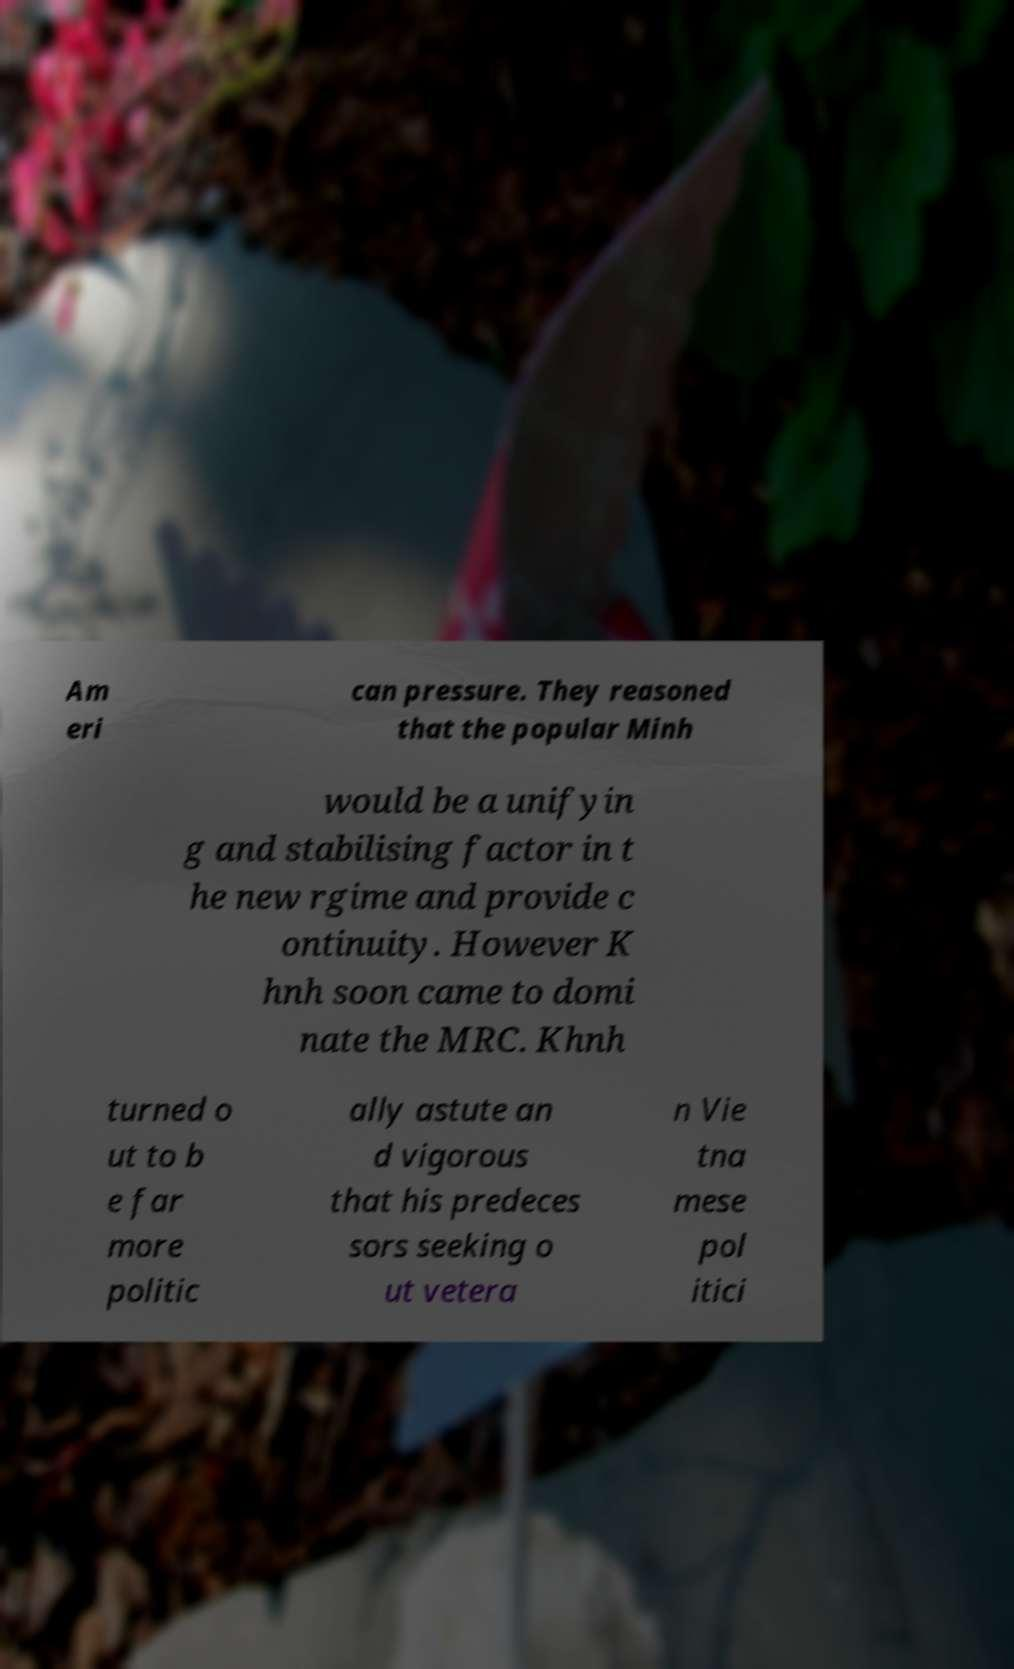Can you read and provide the text displayed in the image?This photo seems to have some interesting text. Can you extract and type it out for me? Am eri can pressure. They reasoned that the popular Minh would be a unifyin g and stabilising factor in t he new rgime and provide c ontinuity. However K hnh soon came to domi nate the MRC. Khnh turned o ut to b e far more politic ally astute an d vigorous that his predeces sors seeking o ut vetera n Vie tna mese pol itici 